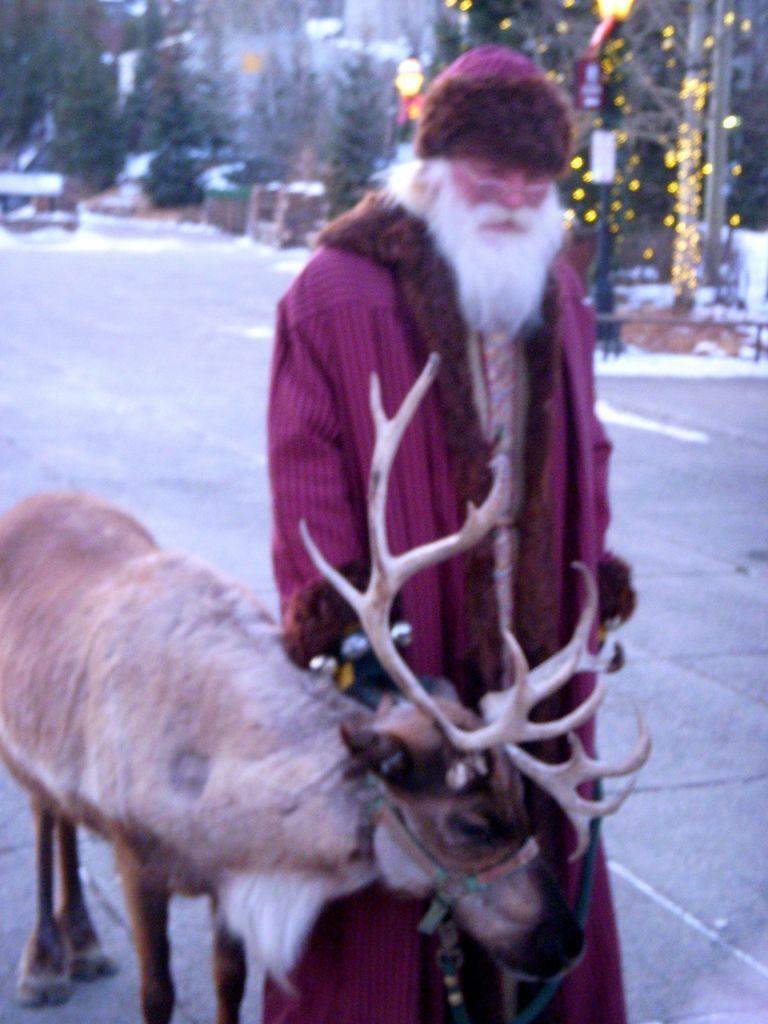In one or two sentences, can you explain what this image depicts? In this image there is a person in a fancy dress is standing, there is a reindeer, snow, trees, lights, pole. 